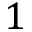<formula> <loc_0><loc_0><loc_500><loc_500>1</formula> 